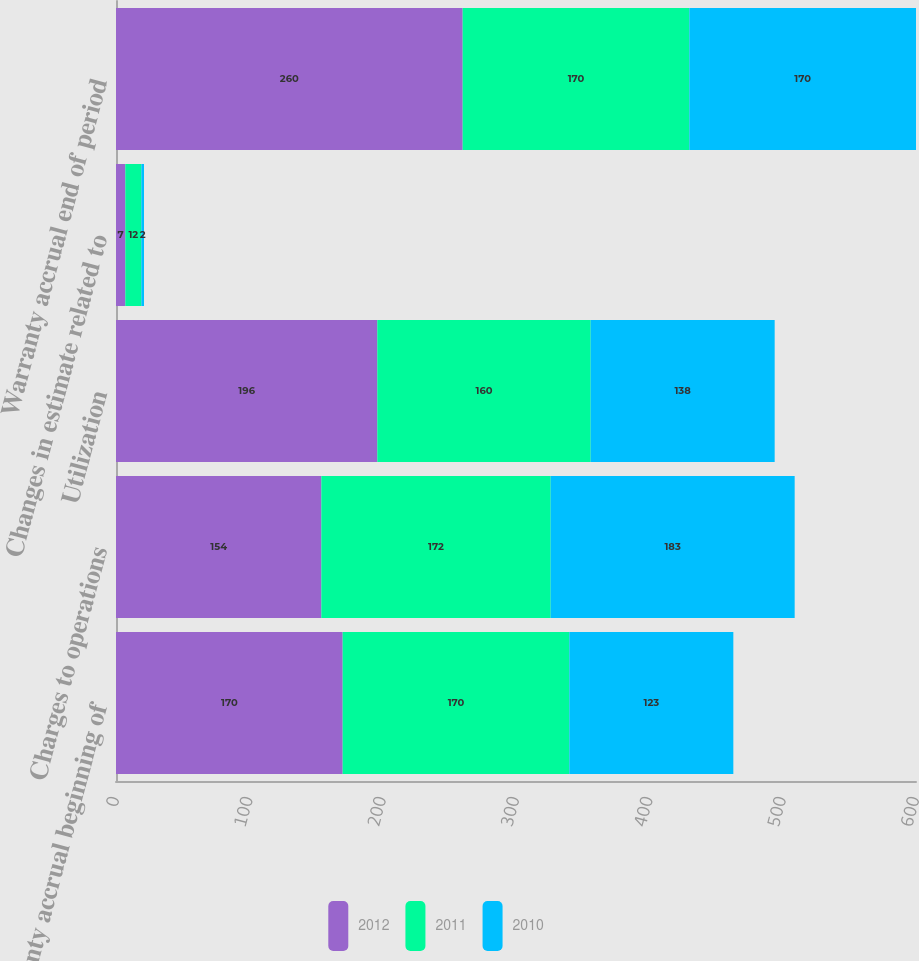<chart> <loc_0><loc_0><loc_500><loc_500><stacked_bar_chart><ecel><fcel>Warranty accrual beginning of<fcel>Charges to operations<fcel>Utilization<fcel>Changes in estimate related to<fcel>Warranty accrual end of period<nl><fcel>2012<fcel>170<fcel>154<fcel>196<fcel>7<fcel>260<nl><fcel>2011<fcel>170<fcel>172<fcel>160<fcel>12<fcel>170<nl><fcel>2010<fcel>123<fcel>183<fcel>138<fcel>2<fcel>170<nl></chart> 